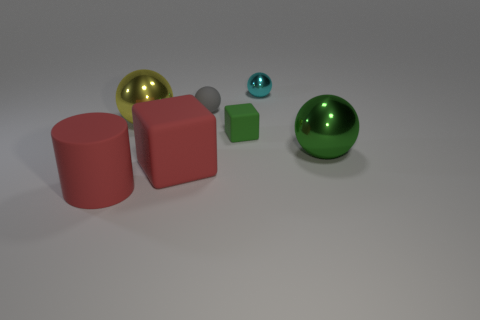Add 2 small red cylinders. How many objects exist? 9 Subtract all spheres. How many objects are left? 3 Subtract all yellow cylinders. Subtract all red objects. How many objects are left? 5 Add 7 small green things. How many small green things are left? 8 Add 7 big metallic balls. How many big metallic balls exist? 9 Subtract 0 purple blocks. How many objects are left? 7 